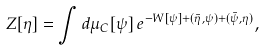<formula> <loc_0><loc_0><loc_500><loc_500>Z [ \eta ] = \int d \mu _ { C } [ \psi ] \, e ^ { - W [ \psi ] + ( \bar { \eta } , \psi ) + ( \bar { \psi } , \eta ) } ,</formula> 